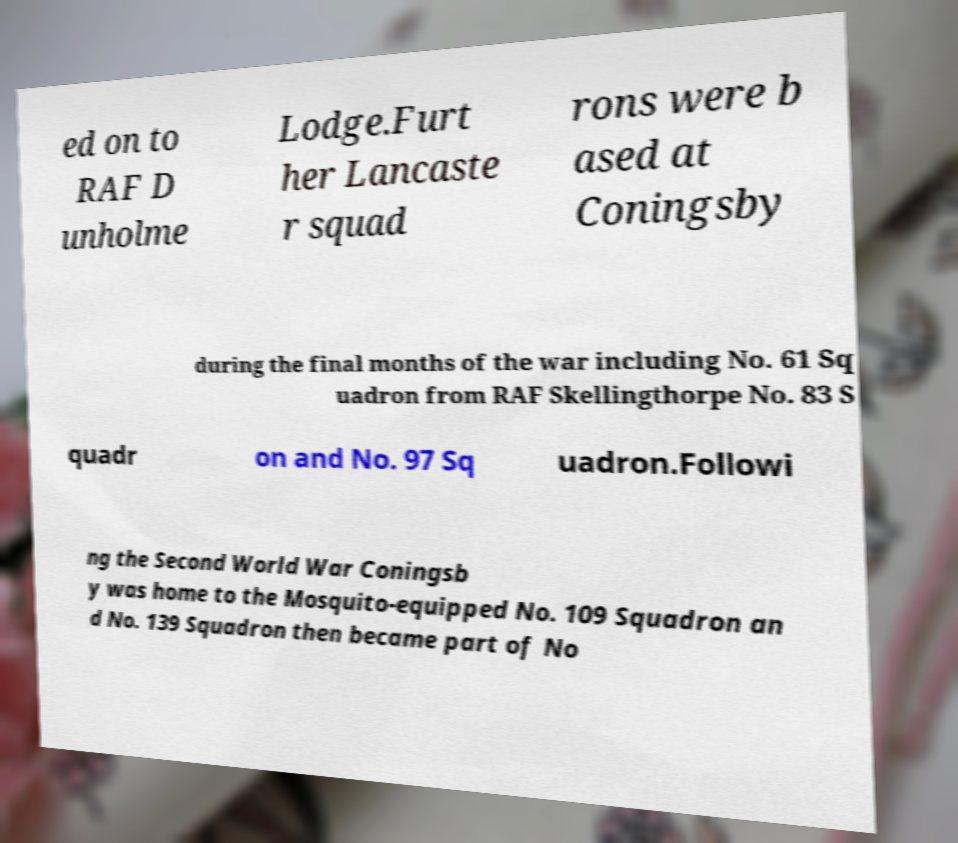There's text embedded in this image that I need extracted. Can you transcribe it verbatim? ed on to RAF D unholme Lodge.Furt her Lancaste r squad rons were b ased at Coningsby during the final months of the war including No. 61 Sq uadron from RAF Skellingthorpe No. 83 S quadr on and No. 97 Sq uadron.Followi ng the Second World War Coningsb y was home to the Mosquito-equipped No. 109 Squadron an d No. 139 Squadron then became part of No 